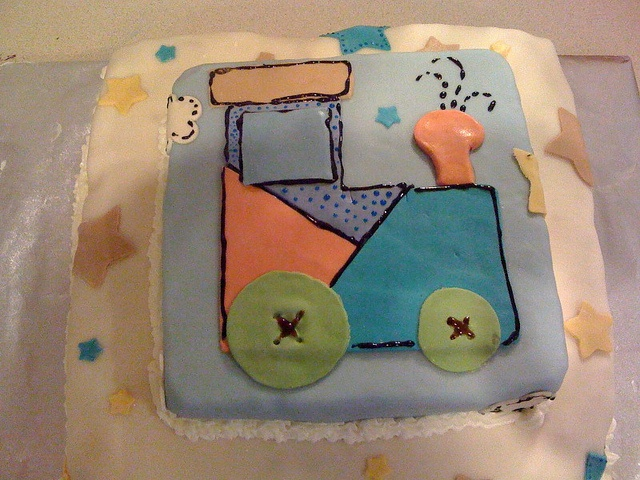Describe the objects in this image and their specific colors. I can see cake in tan, darkgray, and gray tones and cake in tan, teal, and olive tones in this image. 